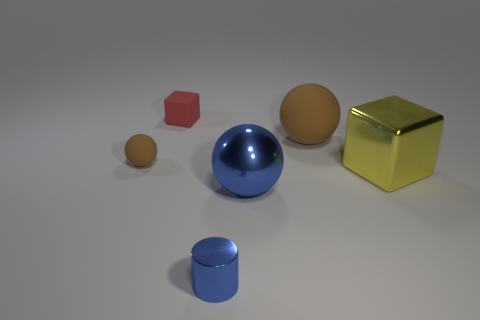What number of big blue rubber cylinders are there?
Provide a succinct answer. 0. Is the small red cube made of the same material as the blue object that is in front of the large blue sphere?
Your answer should be very brief. No. Do the sphere to the right of the big metallic sphere and the metal sphere have the same color?
Provide a succinct answer. No. There is a thing that is in front of the tiny ball and behind the big blue shiny object; what material is it?
Your answer should be very brief. Metal. What is the size of the red block?
Ensure brevity in your answer.  Small. Does the metallic ball have the same color as the big metal thing that is on the right side of the large matte sphere?
Your response must be concise. No. How many other things are there of the same color as the big cube?
Provide a succinct answer. 0. There is a rubber ball on the right side of the tiny metal thing; does it have the same size as the brown rubber ball to the left of the small blue metal thing?
Keep it short and to the point. No. What is the color of the block in front of the small block?
Make the answer very short. Yellow. Are there fewer small red things that are right of the tiny red block than brown metallic things?
Your response must be concise. No. 